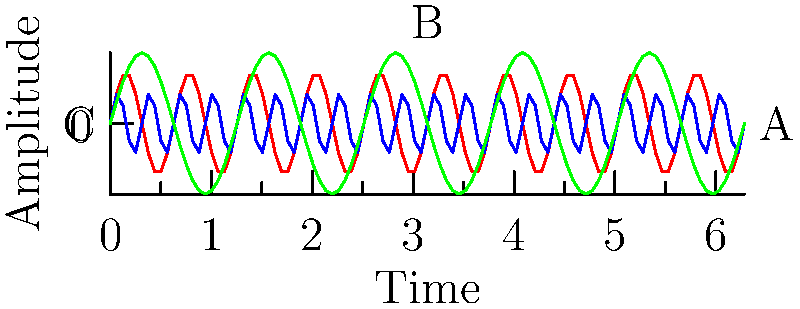Look at these waveforms, supposedly representing different music genres. Which one would you say represents the most "overproduced" and "soulless" modern pop music, according to industry standards? Let's analyze these waveforms from the perspective of an ex-band member who's critical of popular music:

1. Waveform A (red): This shows a moderate frequency and amplitude. It's not too repetitive, which might represent a more traditional or indie sound.

2. Waveform B (blue): This has the highest frequency among the three, with a lower amplitude. The rapid oscillations could represent a busy, electronic-heavy sound typical in modern pop production.

3. Waveform C (green): This has the lowest frequency but the highest amplitude. It might represent a slower, more bass-heavy genre.

From a critical standpoint of modern pop music:

- High frequency often correlates with a busy, overproduced sound.
- Lower amplitude in pop often results from heavy compression, a technique criticized for reducing dynamic range.
- Repetitive patterns are often associated with formulaic songwriting.

Waveform B exhibits these characteristics most strongly: high frequency (busy sound), lower amplitude (possible over-compression), and a very repetitive pattern. This aligns with common criticisms of modern pop as being overproduced and lacking in musical depth or "soul."
Answer: Waveform B (blue) 